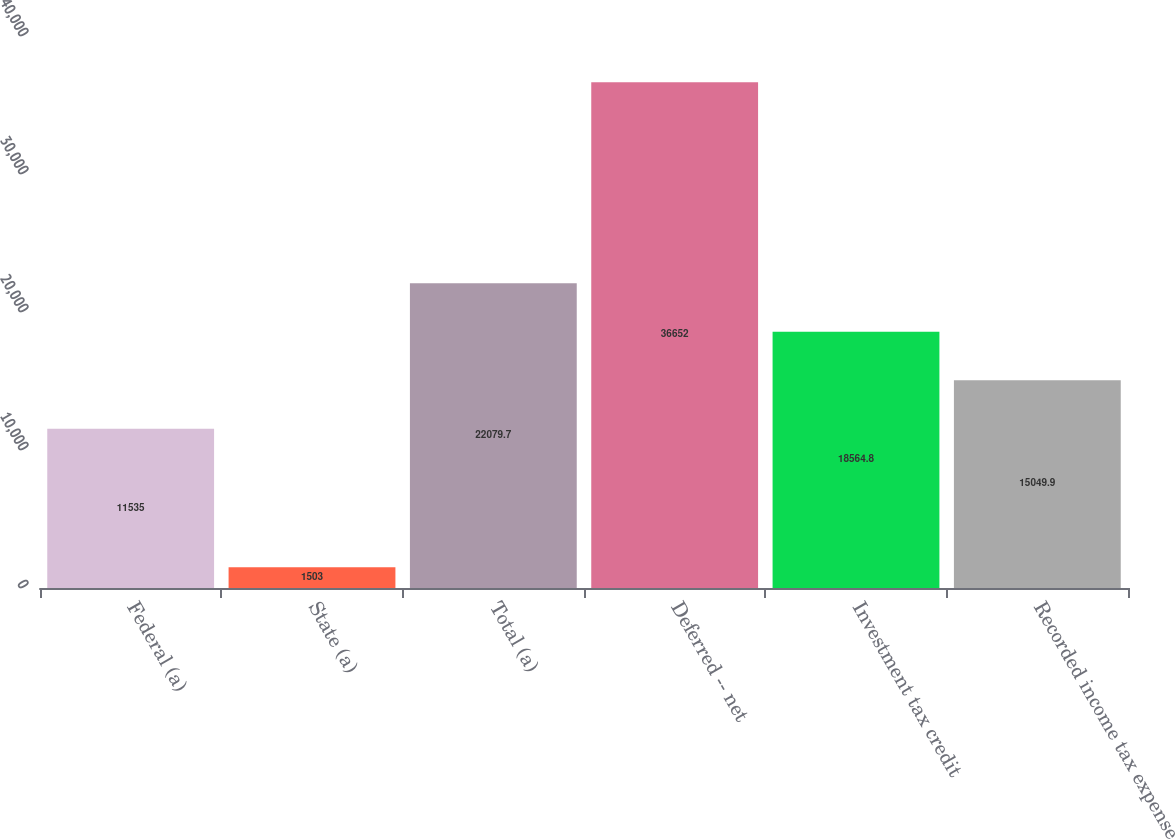Convert chart to OTSL. <chart><loc_0><loc_0><loc_500><loc_500><bar_chart><fcel>Federal (a)<fcel>State (a)<fcel>Total (a)<fcel>Deferred -- net<fcel>Investment tax credit<fcel>Recorded income tax expense<nl><fcel>11535<fcel>1503<fcel>22079.7<fcel>36652<fcel>18564.8<fcel>15049.9<nl></chart> 